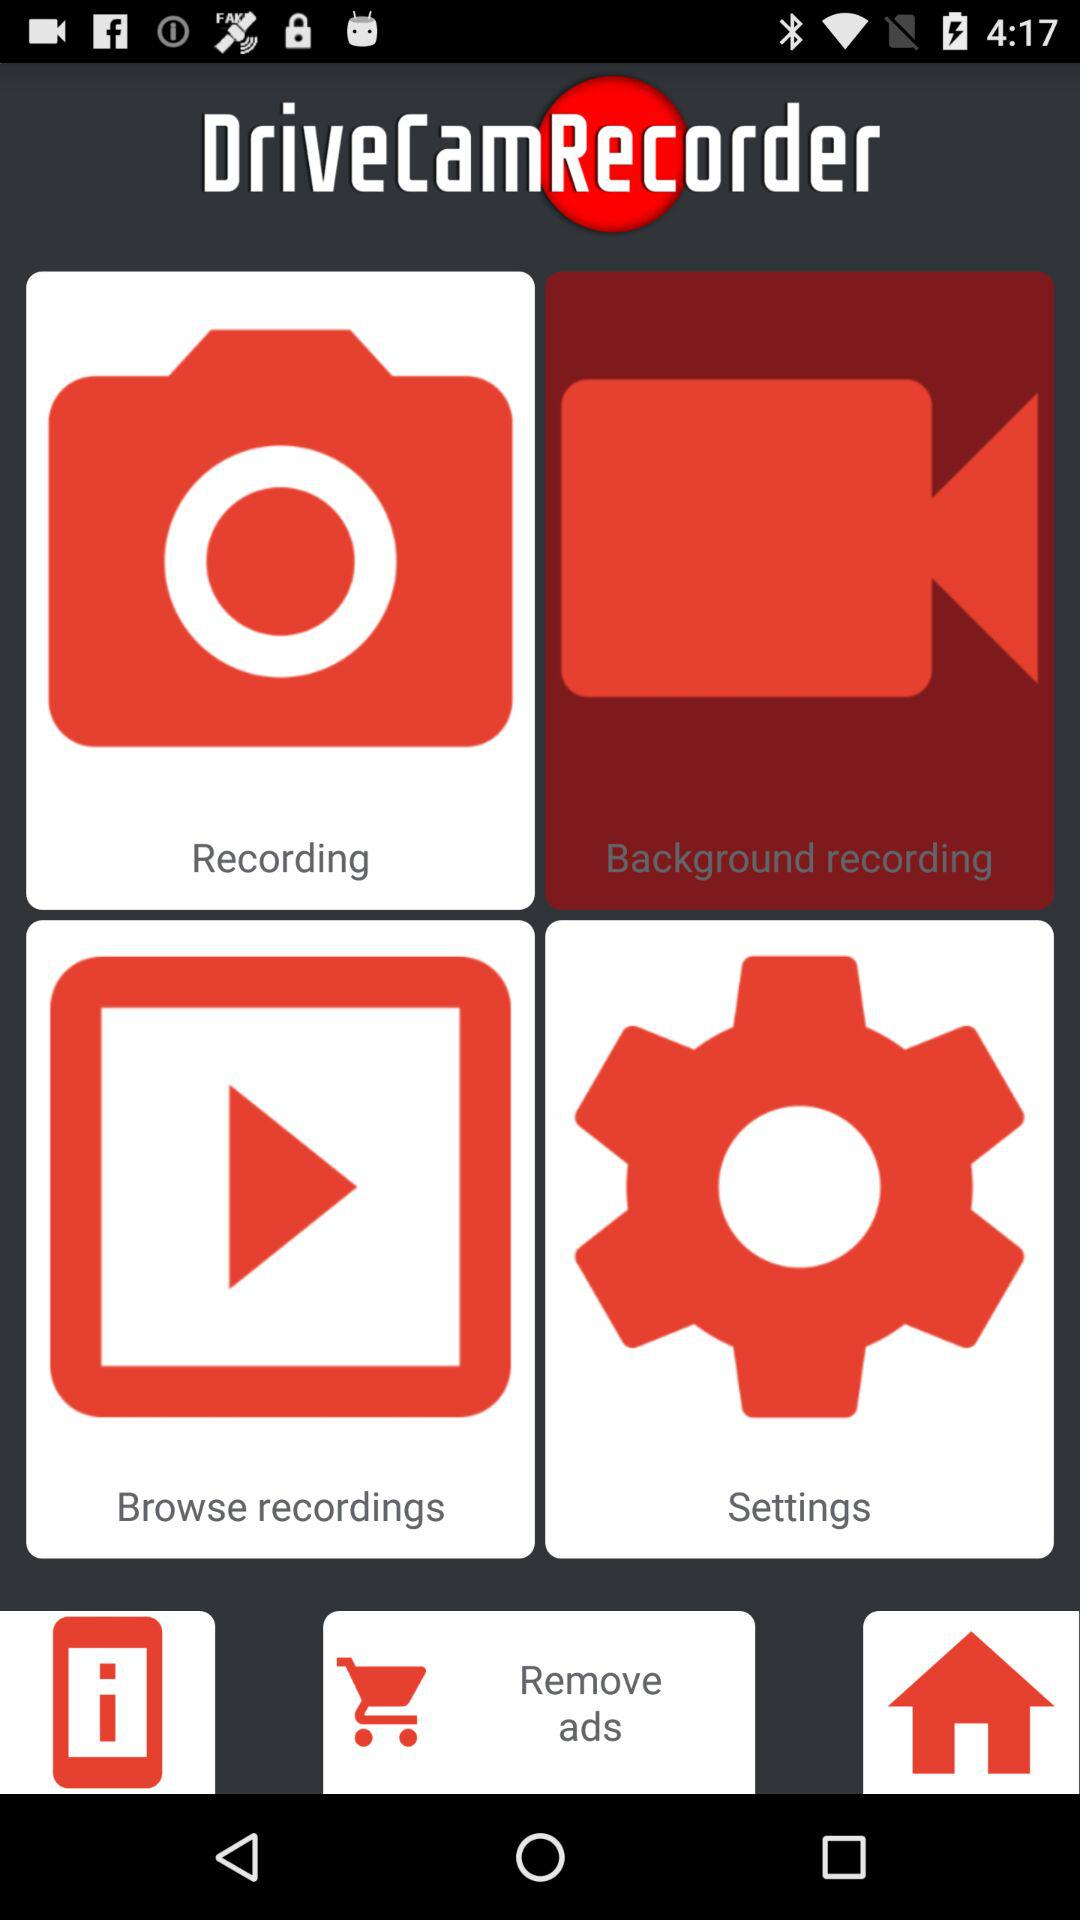How many new features are mentioned in the release notes?
Answer the question using a single word or phrase. 6 